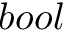Convert formula to latex. <formula><loc_0><loc_0><loc_500><loc_500>b o o l</formula> 